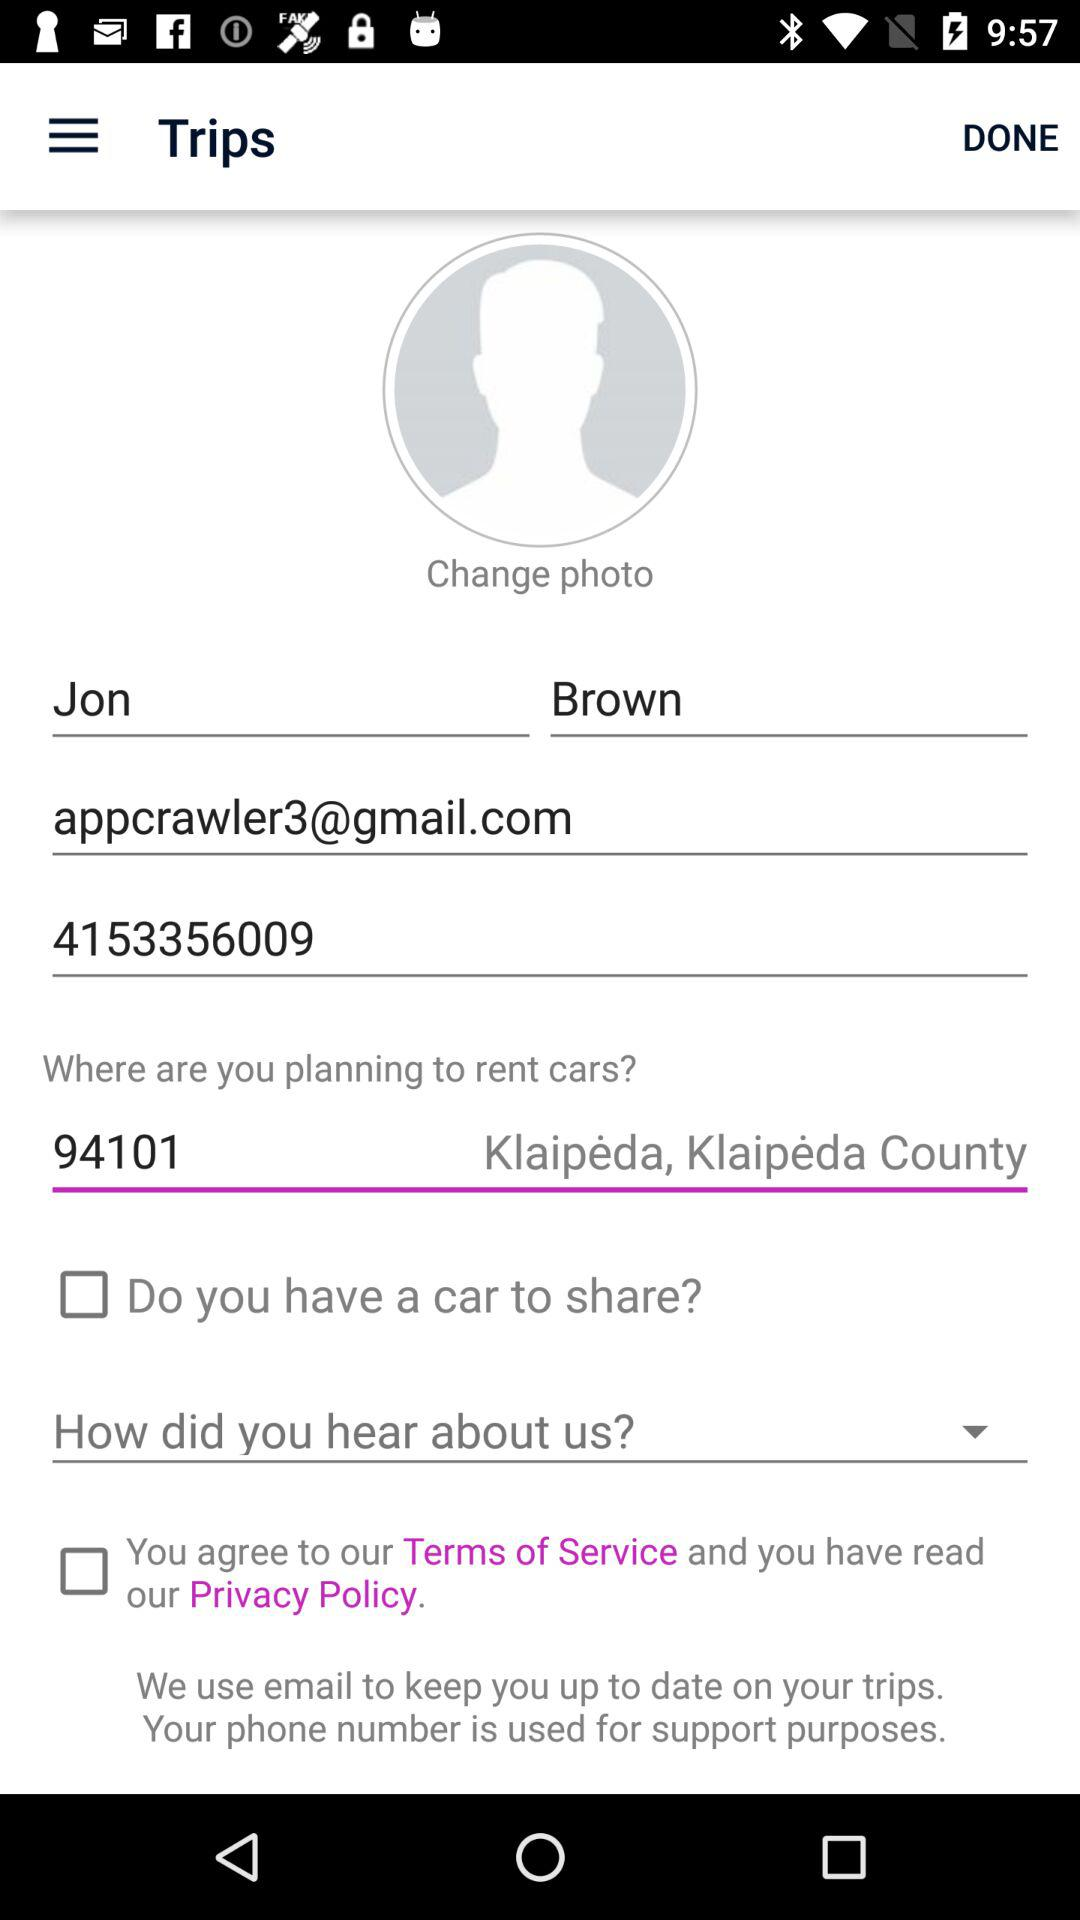What is the email address? The email address is appcrawler3@gmail.com. 